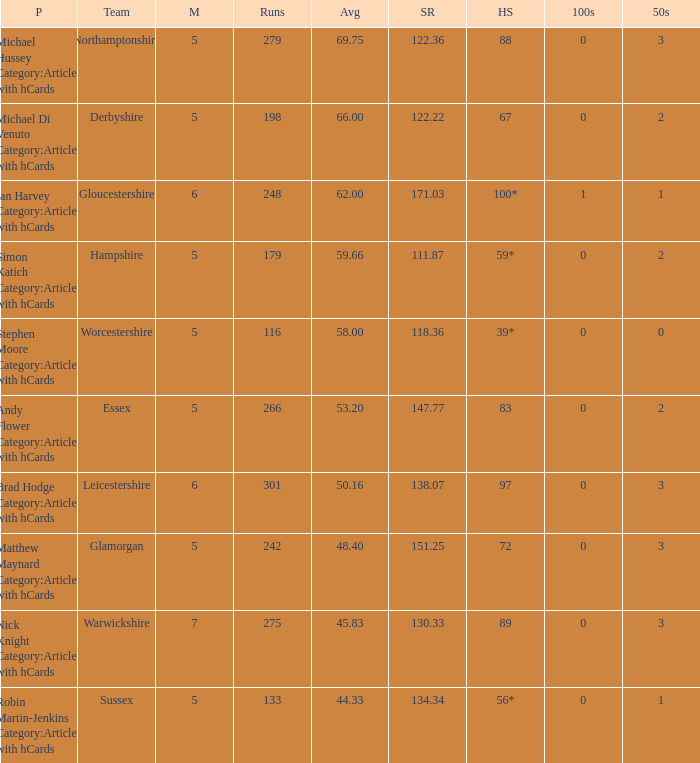If the team is Gloucestershire, what is the average? 62.0. 